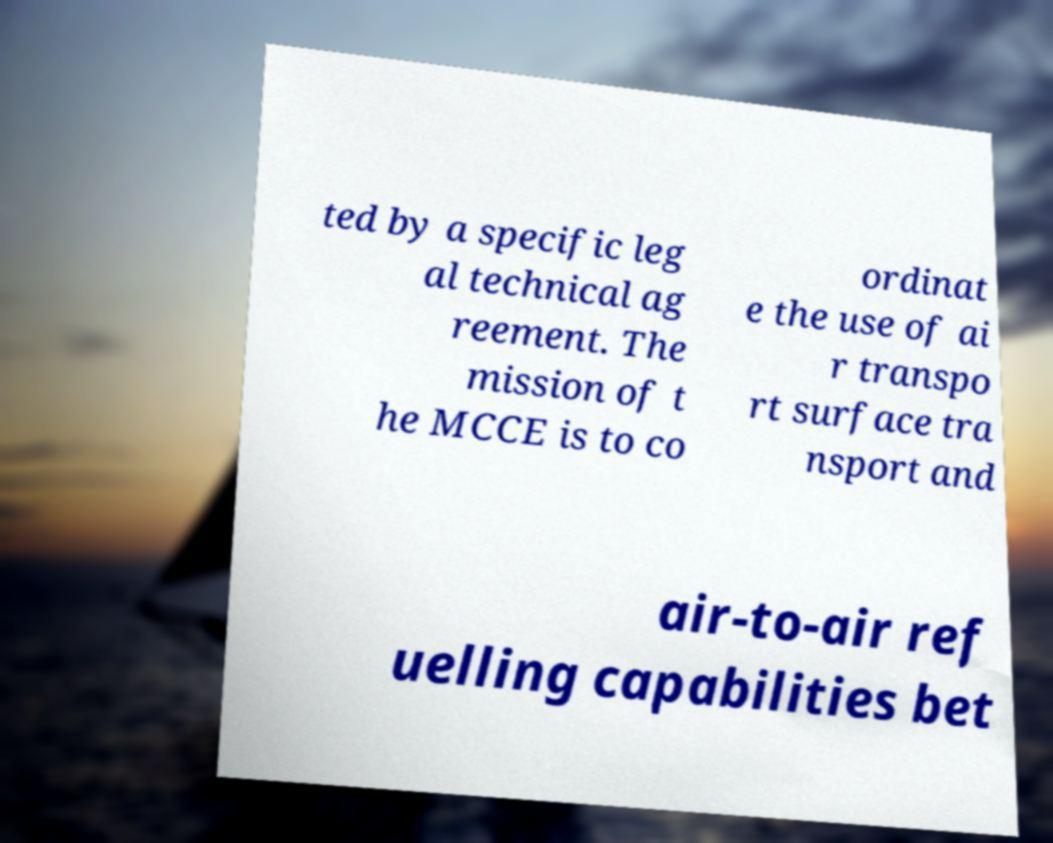For documentation purposes, I need the text within this image transcribed. Could you provide that? ted by a specific leg al technical ag reement. The mission of t he MCCE is to co ordinat e the use of ai r transpo rt surface tra nsport and air-to-air ref uelling capabilities bet 